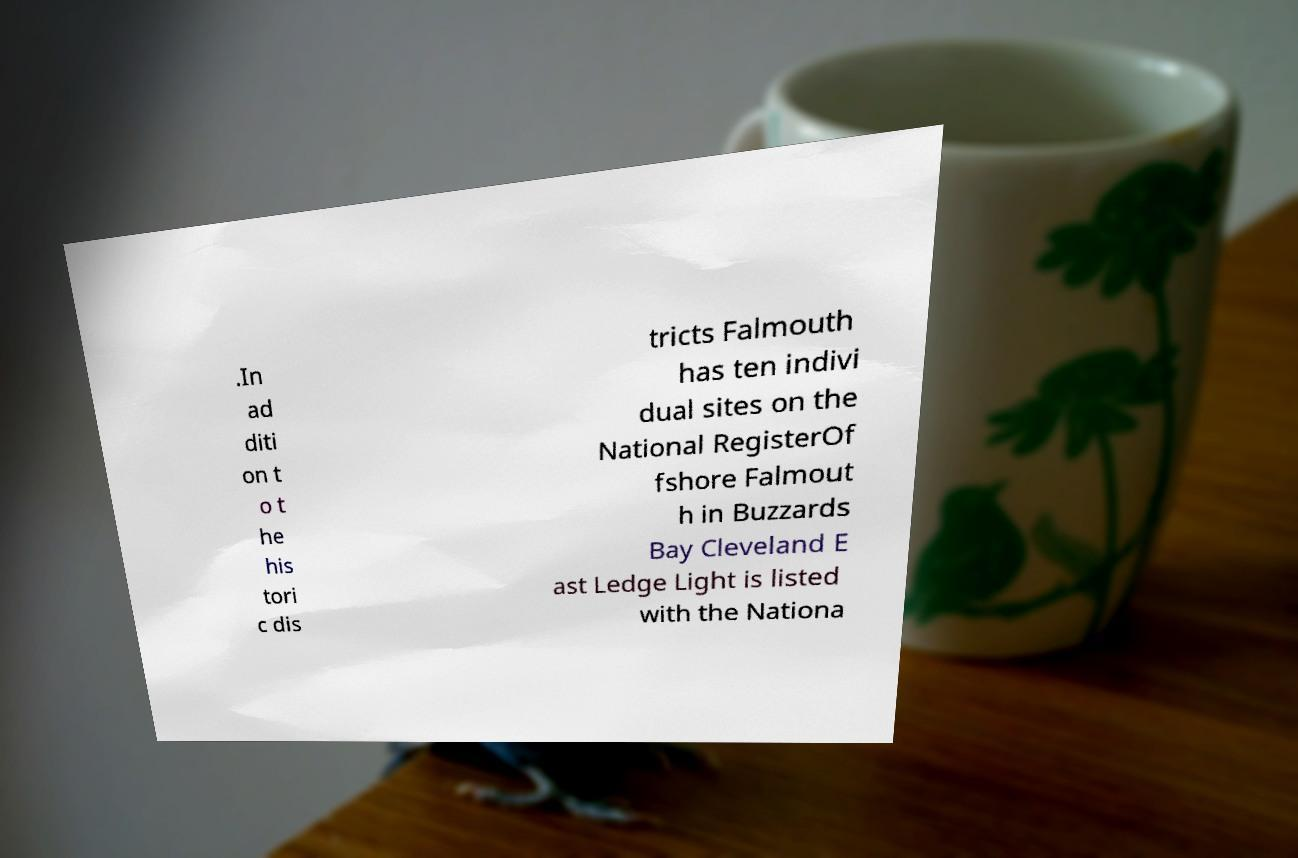Could you extract and type out the text from this image? .In ad diti on t o t he his tori c dis tricts Falmouth has ten indivi dual sites on the National RegisterOf fshore Falmout h in Buzzards Bay Cleveland E ast Ledge Light is listed with the Nationa 